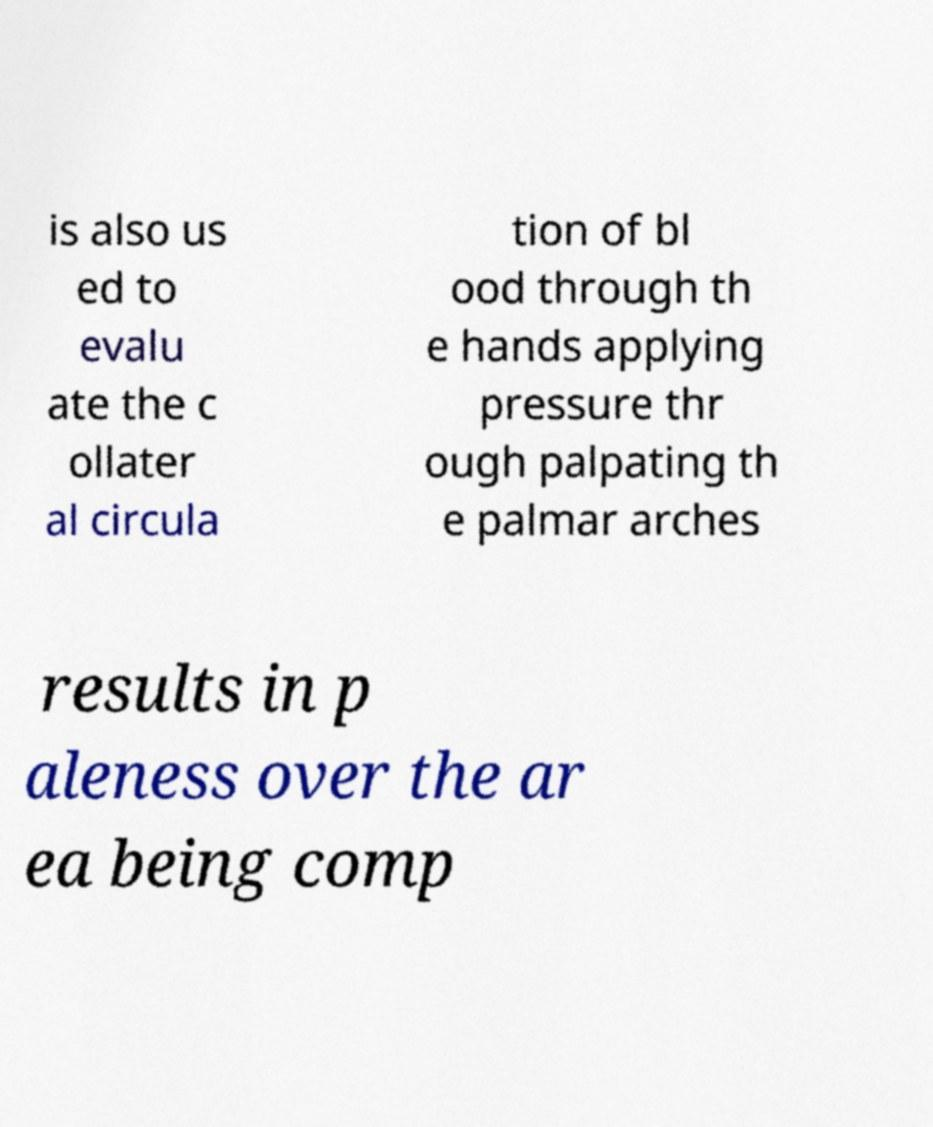Can you accurately transcribe the text from the provided image for me? is also us ed to evalu ate the c ollater al circula tion of bl ood through th e hands applying pressure thr ough palpating th e palmar arches results in p aleness over the ar ea being comp 